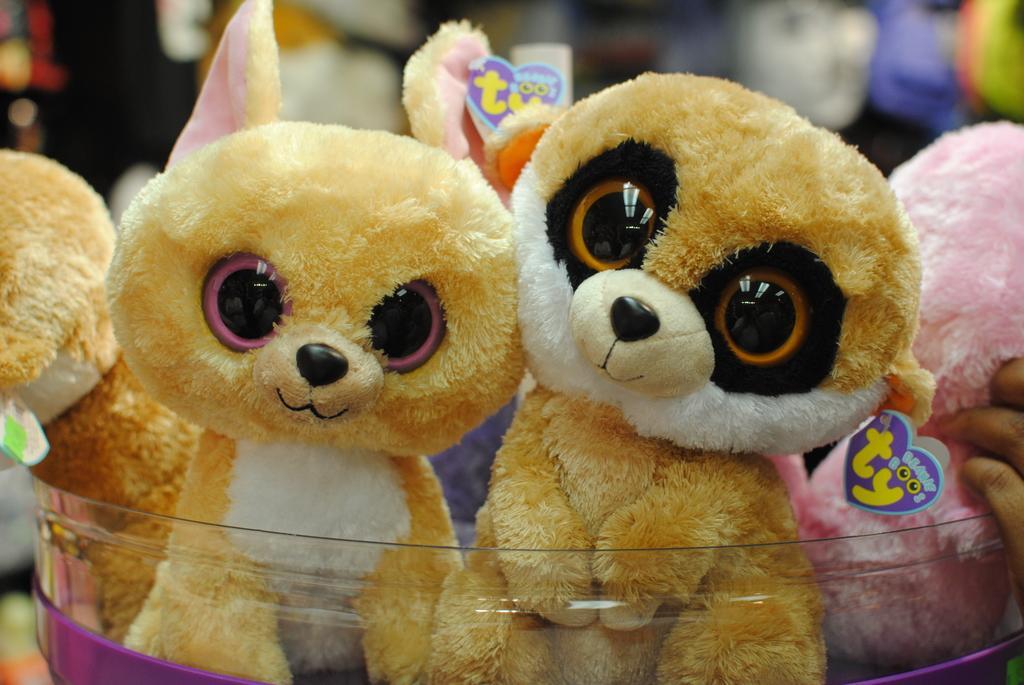How would you summarize this image in a sentence or two? This image is taken indoors. In this image the background is a little blurred. There are a few toys. At the bottom of the image there is a tub and there are a few toys in the tub. 